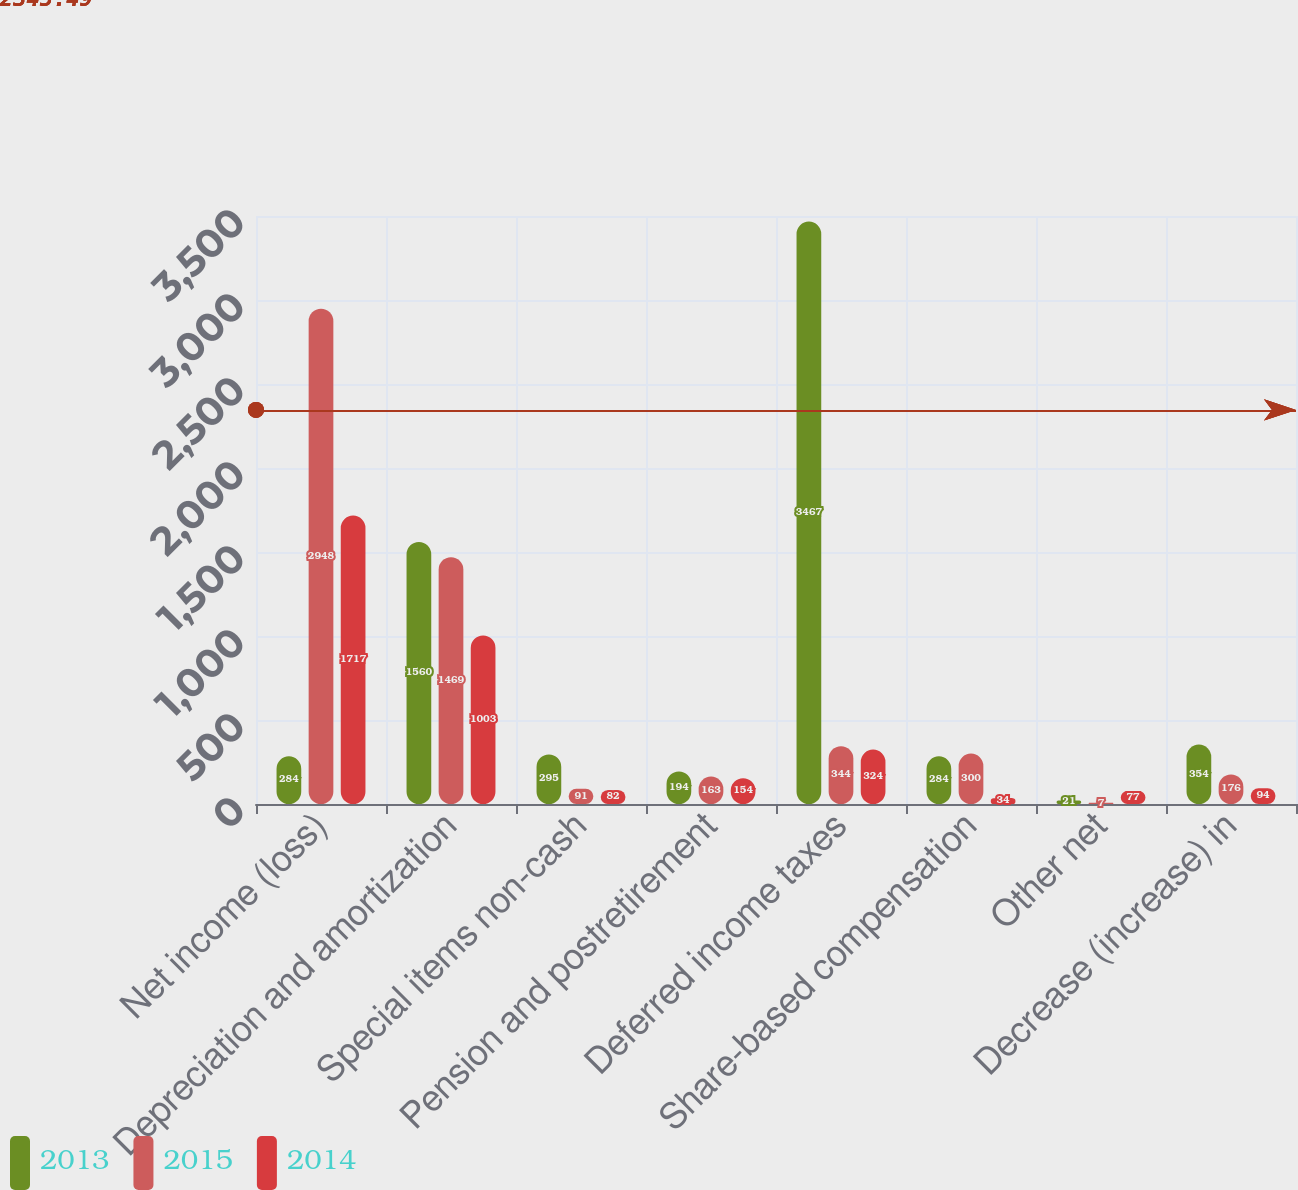<chart> <loc_0><loc_0><loc_500><loc_500><stacked_bar_chart><ecel><fcel>Net income (loss)<fcel>Depreciation and amortization<fcel>Special items non-cash<fcel>Pension and postretirement<fcel>Deferred income taxes<fcel>Share-based compensation<fcel>Other net<fcel>Decrease (increase) in<nl><fcel>2013<fcel>284<fcel>1560<fcel>295<fcel>194<fcel>3467<fcel>284<fcel>21<fcel>354<nl><fcel>2015<fcel>2948<fcel>1469<fcel>91<fcel>163<fcel>344<fcel>300<fcel>7<fcel>176<nl><fcel>2014<fcel>1717<fcel>1003<fcel>82<fcel>154<fcel>324<fcel>34<fcel>77<fcel>94<nl></chart> 